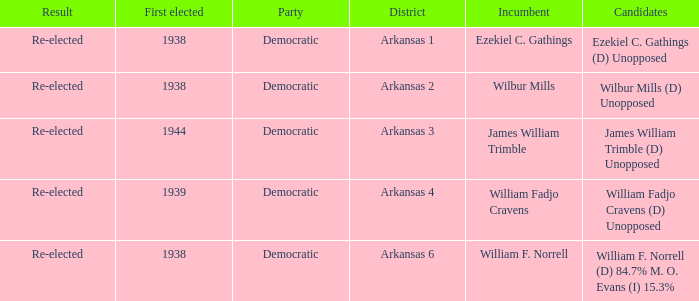Can you parse all the data within this table? {'header': ['Result', 'First elected', 'Party', 'District', 'Incumbent', 'Candidates'], 'rows': [['Re-elected', '1938', 'Democratic', 'Arkansas 1', 'Ezekiel C. Gathings', 'Ezekiel C. Gathings (D) Unopposed'], ['Re-elected', '1938', 'Democratic', 'Arkansas 2', 'Wilbur Mills', 'Wilbur Mills (D) Unopposed'], ['Re-elected', '1944', 'Democratic', 'Arkansas 3', 'James William Trimble', 'James William Trimble (D) Unopposed'], ['Re-elected', '1939', 'Democratic', 'Arkansas 4', 'William Fadjo Cravens', 'William Fadjo Cravens (D) Unopposed'], ['Re-elected', '1938', 'Democratic', 'Arkansas 6', 'William F. Norrell', 'William F. Norrell (D) 84.7% M. O. Evans (I) 15.3%']]} How many incumbents had a district of Arkansas 3? 1.0. 